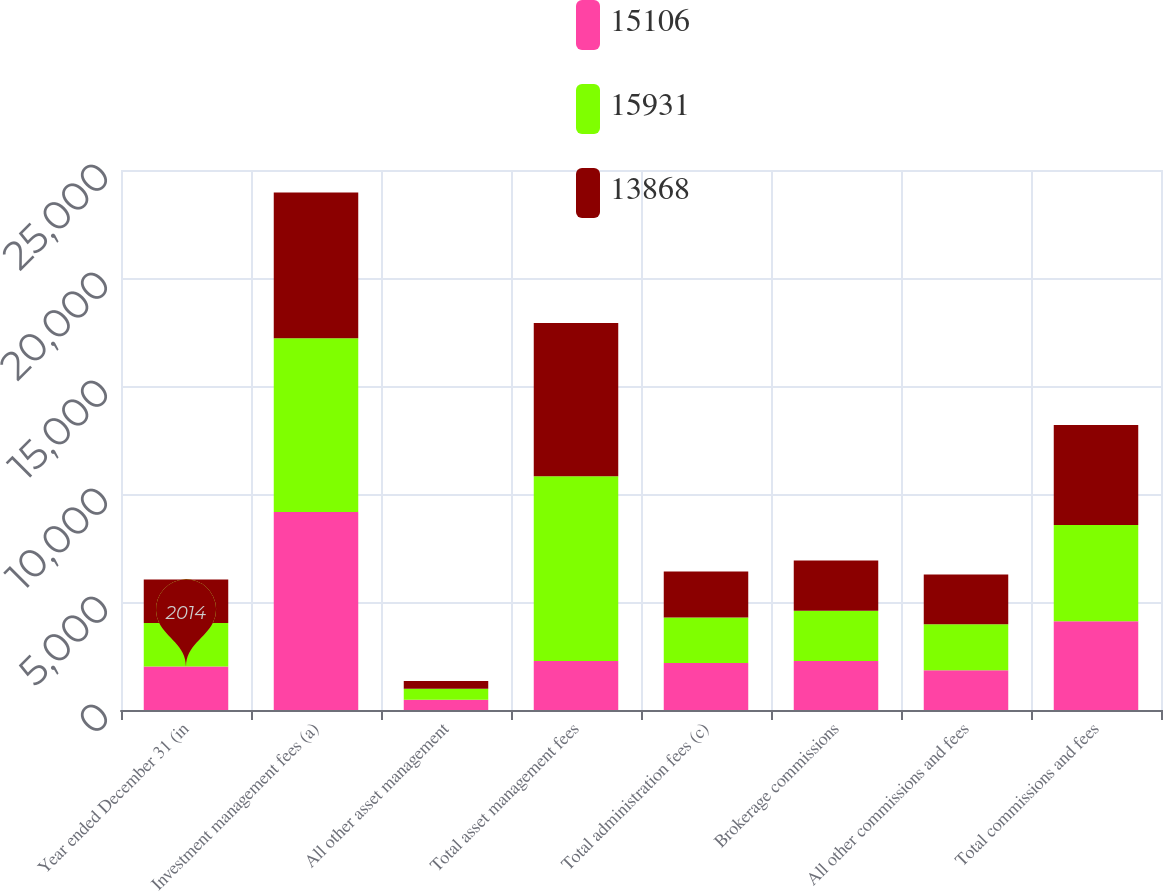Convert chart. <chart><loc_0><loc_0><loc_500><loc_500><stacked_bar_chart><ecel><fcel>Year ended December 31 (in<fcel>Investment management fees (a)<fcel>All other asset management<fcel>Total asset management fees<fcel>Total administration fees (c)<fcel>Brokerage commissions<fcel>All other commissions and fees<fcel>Total commissions and fees<nl><fcel>15106<fcel>2014<fcel>9169<fcel>477<fcel>2270<fcel>2179<fcel>2270<fcel>1836<fcel>4106<nl><fcel>15931<fcel>2013<fcel>8044<fcel>505<fcel>8549<fcel>2101<fcel>2321<fcel>2135<fcel>4456<nl><fcel>13868<fcel>2012<fcel>6744<fcel>357<fcel>7101<fcel>2135<fcel>2331<fcel>2301<fcel>4632<nl></chart> 